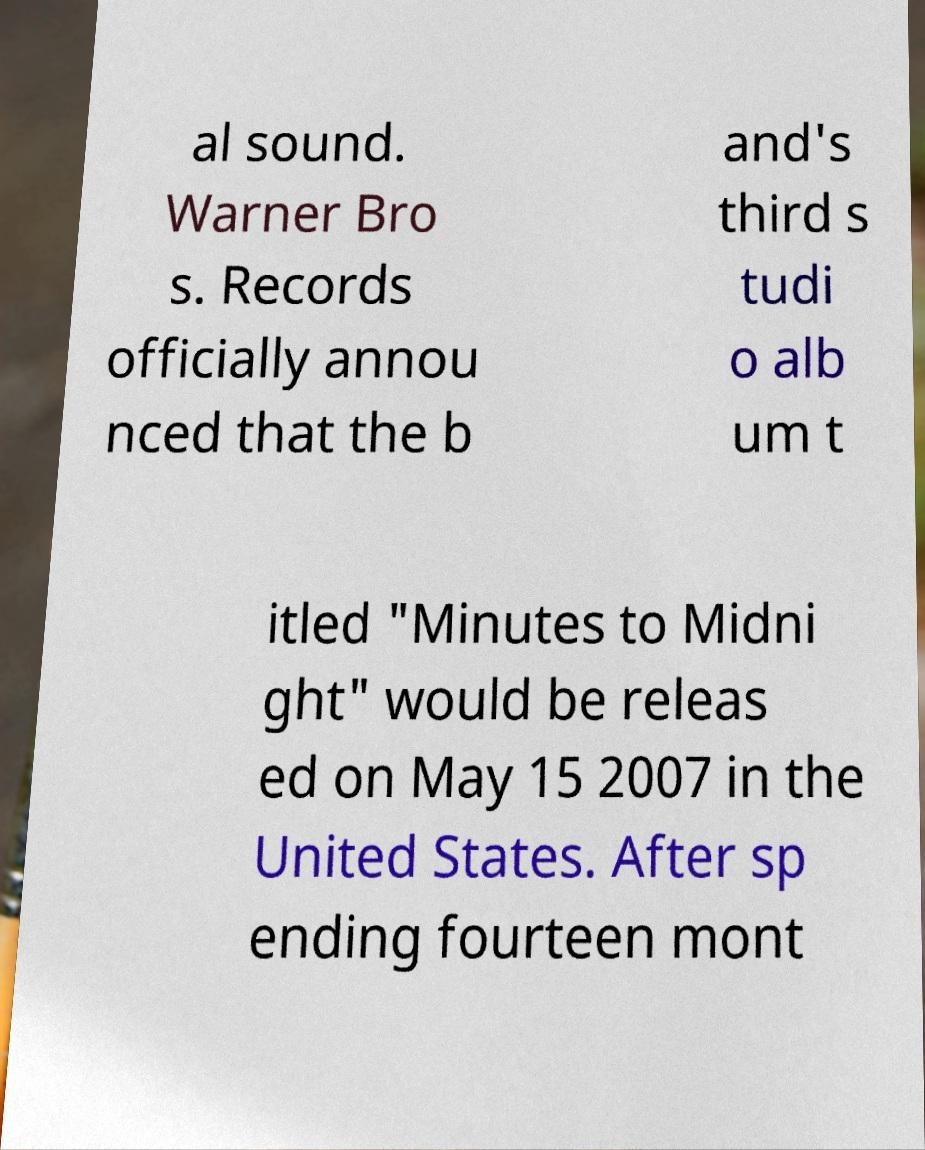Could you assist in decoding the text presented in this image and type it out clearly? al sound. Warner Bro s. Records officially annou nced that the b and's third s tudi o alb um t itled "Minutes to Midni ght" would be releas ed on May 15 2007 in the United States. After sp ending fourteen mont 